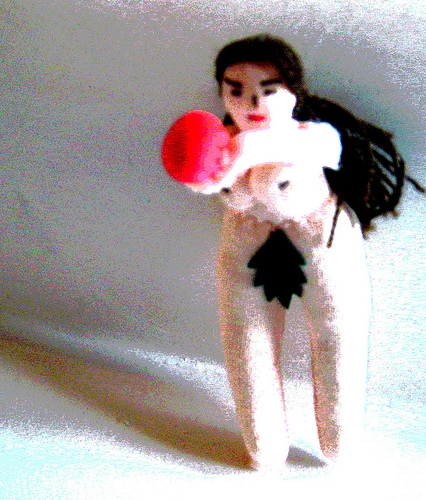<image>
Can you confirm if the naked doll is on the hat? No. The naked doll is not positioned on the hat. They may be near each other, but the naked doll is not supported by or resting on top of the hat. 